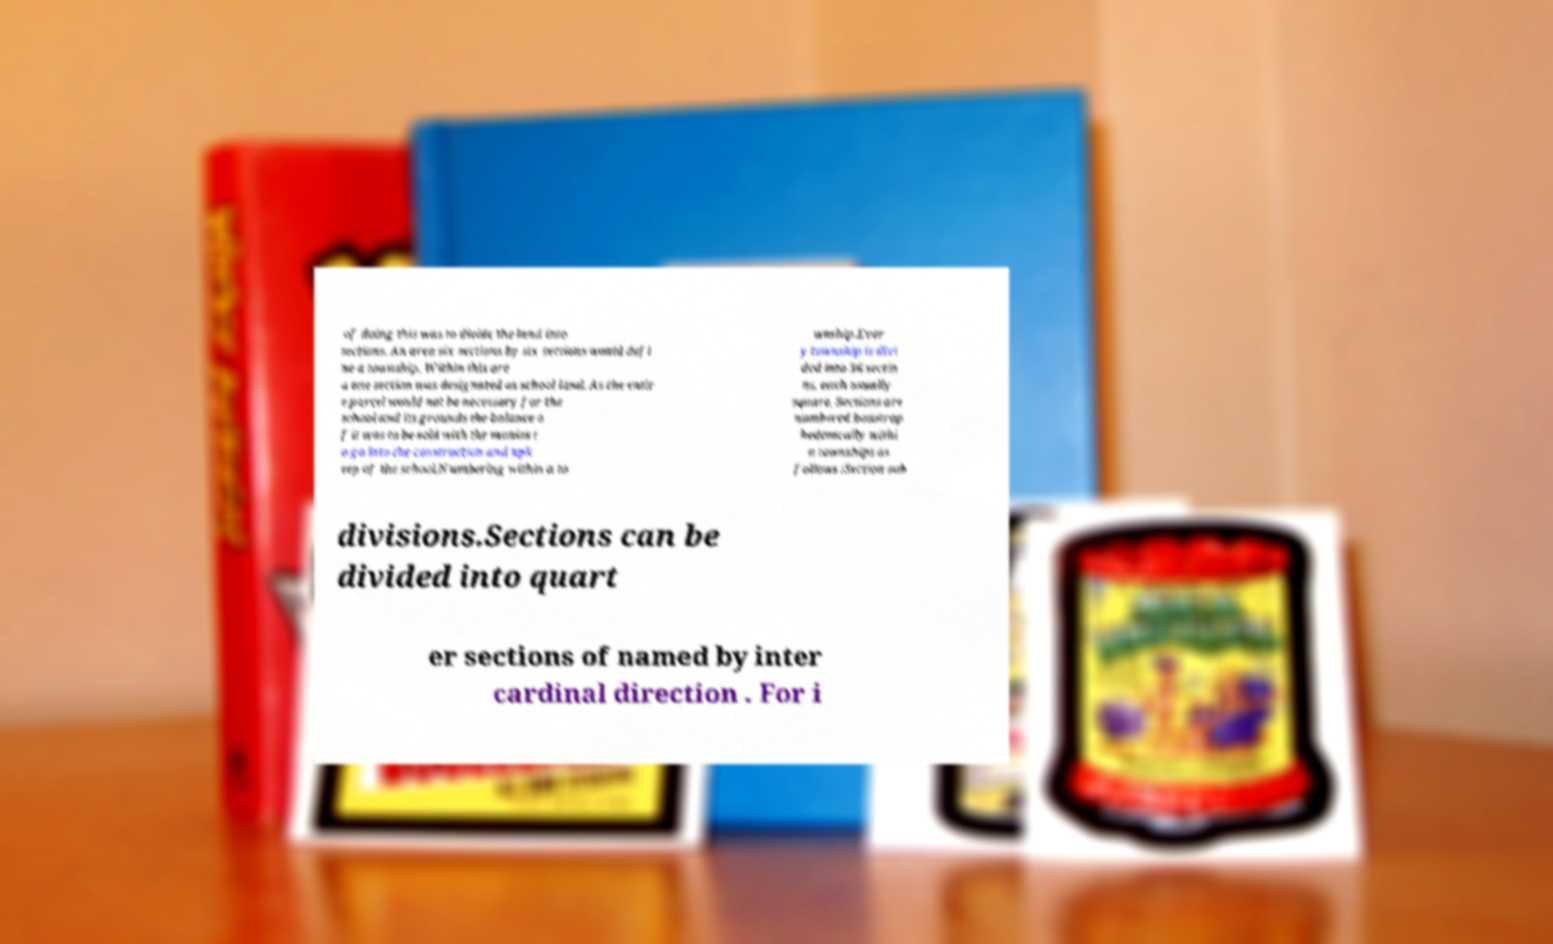I need the written content from this picture converted into text. Can you do that? of doing this was to divide the land into sections. An area six sections by six sections would defi ne a township. Within this are a one section was designated as school land. As the entir e parcel would not be necessary for the school and its grounds the balance o f it was to be sold with the monies t o go into the construction and upk eep of the school.Numbering within a to wnship.Ever y township is divi ded into 36 sectio ns, each usually square. Sections are numbered boustrop hedonically withi n townships as follows :Section sub divisions.Sections can be divided into quart er sections of named by inter cardinal direction . For i 